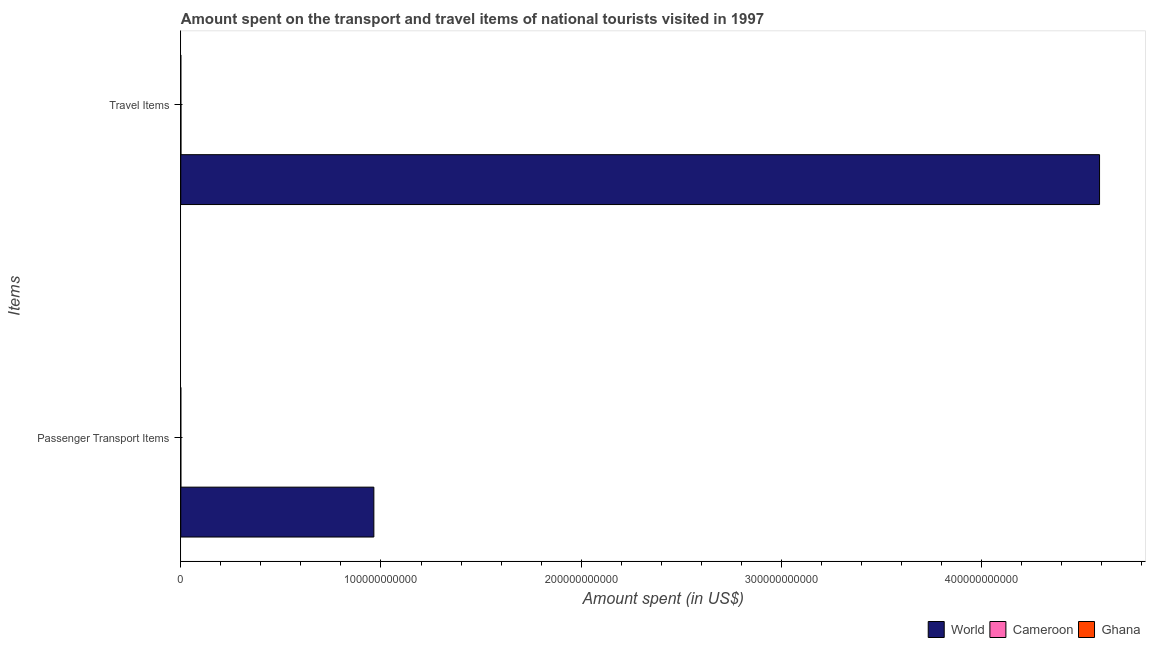How many different coloured bars are there?
Make the answer very short. 3. Are the number of bars per tick equal to the number of legend labels?
Keep it short and to the point. Yes. What is the label of the 2nd group of bars from the top?
Give a very brief answer. Passenger Transport Items. Across all countries, what is the maximum amount spent on passenger transport items?
Provide a succinct answer. 9.64e+1. What is the total amount spent in travel items in the graph?
Provide a short and direct response. 4.59e+11. What is the difference between the amount spent in travel items in World and that in Ghana?
Your answer should be very brief. 4.59e+11. What is the difference between the amount spent in travel items in Ghana and the amount spent on passenger transport items in Cameroon?
Provide a succinct answer. -2.00e+07. What is the average amount spent on passenger transport items per country?
Give a very brief answer. 3.22e+1. What is the difference between the amount spent in travel items and amount spent on passenger transport items in Cameroon?
Offer a very short reply. 4.90e+07. In how many countries, is the amount spent in travel items greater than 180000000000 US$?
Give a very brief answer. 1. What is the ratio of the amount spent on passenger transport items in World to that in Cameroon?
Ensure brevity in your answer.  2755.49. In how many countries, is the amount spent in travel items greater than the average amount spent in travel items taken over all countries?
Provide a short and direct response. 1. What does the 3rd bar from the top in Passenger Transport Items represents?
Make the answer very short. World. What does the 2nd bar from the bottom in Travel Items represents?
Give a very brief answer. Cameroon. How many bars are there?
Provide a short and direct response. 6. How many countries are there in the graph?
Your answer should be very brief. 3. What is the difference between two consecutive major ticks on the X-axis?
Your response must be concise. 1.00e+11. Where does the legend appear in the graph?
Your answer should be very brief. Bottom right. How are the legend labels stacked?
Keep it short and to the point. Horizontal. What is the title of the graph?
Offer a very short reply. Amount spent on the transport and travel items of national tourists visited in 1997. What is the label or title of the X-axis?
Your answer should be very brief. Amount spent (in US$). What is the label or title of the Y-axis?
Provide a succinct answer. Items. What is the Amount spent (in US$) of World in Passenger Transport Items?
Offer a terse response. 9.64e+1. What is the Amount spent (in US$) of Cameroon in Passenger Transport Items?
Make the answer very short. 3.50e+07. What is the Amount spent (in US$) in Ghana in Passenger Transport Items?
Your answer should be compact. 2.00e+07. What is the Amount spent (in US$) in World in Travel Items?
Give a very brief answer. 4.59e+11. What is the Amount spent (in US$) in Cameroon in Travel Items?
Offer a terse response. 8.40e+07. What is the Amount spent (in US$) in Ghana in Travel Items?
Make the answer very short. 1.50e+07. Across all Items, what is the maximum Amount spent (in US$) of World?
Your answer should be compact. 4.59e+11. Across all Items, what is the maximum Amount spent (in US$) in Cameroon?
Provide a short and direct response. 8.40e+07. Across all Items, what is the maximum Amount spent (in US$) in Ghana?
Ensure brevity in your answer.  2.00e+07. Across all Items, what is the minimum Amount spent (in US$) in World?
Your response must be concise. 9.64e+1. Across all Items, what is the minimum Amount spent (in US$) in Cameroon?
Provide a succinct answer. 3.50e+07. Across all Items, what is the minimum Amount spent (in US$) in Ghana?
Your answer should be compact. 1.50e+07. What is the total Amount spent (in US$) of World in the graph?
Your response must be concise. 5.55e+11. What is the total Amount spent (in US$) in Cameroon in the graph?
Make the answer very short. 1.19e+08. What is the total Amount spent (in US$) of Ghana in the graph?
Give a very brief answer. 3.50e+07. What is the difference between the Amount spent (in US$) of World in Passenger Transport Items and that in Travel Items?
Make the answer very short. -3.62e+11. What is the difference between the Amount spent (in US$) of Cameroon in Passenger Transport Items and that in Travel Items?
Your answer should be compact. -4.90e+07. What is the difference between the Amount spent (in US$) of World in Passenger Transport Items and the Amount spent (in US$) of Cameroon in Travel Items?
Offer a terse response. 9.64e+1. What is the difference between the Amount spent (in US$) in World in Passenger Transport Items and the Amount spent (in US$) in Ghana in Travel Items?
Ensure brevity in your answer.  9.64e+1. What is the average Amount spent (in US$) of World per Items?
Provide a short and direct response. 2.78e+11. What is the average Amount spent (in US$) of Cameroon per Items?
Your response must be concise. 5.95e+07. What is the average Amount spent (in US$) of Ghana per Items?
Provide a short and direct response. 1.75e+07. What is the difference between the Amount spent (in US$) in World and Amount spent (in US$) in Cameroon in Passenger Transport Items?
Provide a succinct answer. 9.64e+1. What is the difference between the Amount spent (in US$) in World and Amount spent (in US$) in Ghana in Passenger Transport Items?
Offer a very short reply. 9.64e+1. What is the difference between the Amount spent (in US$) of Cameroon and Amount spent (in US$) of Ghana in Passenger Transport Items?
Give a very brief answer. 1.50e+07. What is the difference between the Amount spent (in US$) in World and Amount spent (in US$) in Cameroon in Travel Items?
Offer a very short reply. 4.59e+11. What is the difference between the Amount spent (in US$) of World and Amount spent (in US$) of Ghana in Travel Items?
Ensure brevity in your answer.  4.59e+11. What is the difference between the Amount spent (in US$) of Cameroon and Amount spent (in US$) of Ghana in Travel Items?
Your answer should be very brief. 6.90e+07. What is the ratio of the Amount spent (in US$) of World in Passenger Transport Items to that in Travel Items?
Make the answer very short. 0.21. What is the ratio of the Amount spent (in US$) of Cameroon in Passenger Transport Items to that in Travel Items?
Your answer should be compact. 0.42. What is the ratio of the Amount spent (in US$) of Ghana in Passenger Transport Items to that in Travel Items?
Your answer should be compact. 1.33. What is the difference between the highest and the second highest Amount spent (in US$) in World?
Your response must be concise. 3.62e+11. What is the difference between the highest and the second highest Amount spent (in US$) in Cameroon?
Your answer should be very brief. 4.90e+07. What is the difference between the highest and the second highest Amount spent (in US$) of Ghana?
Keep it short and to the point. 5.00e+06. What is the difference between the highest and the lowest Amount spent (in US$) in World?
Offer a very short reply. 3.62e+11. What is the difference between the highest and the lowest Amount spent (in US$) in Cameroon?
Your answer should be compact. 4.90e+07. 